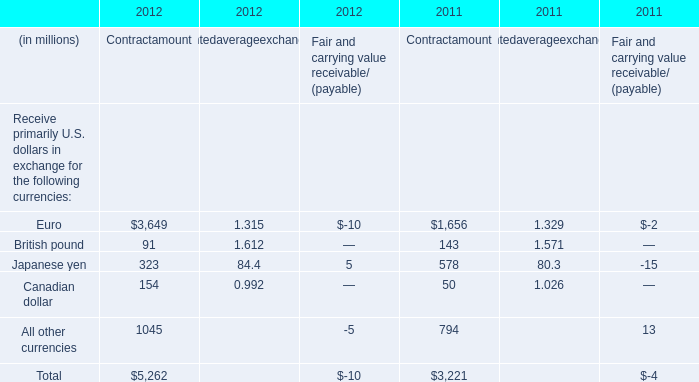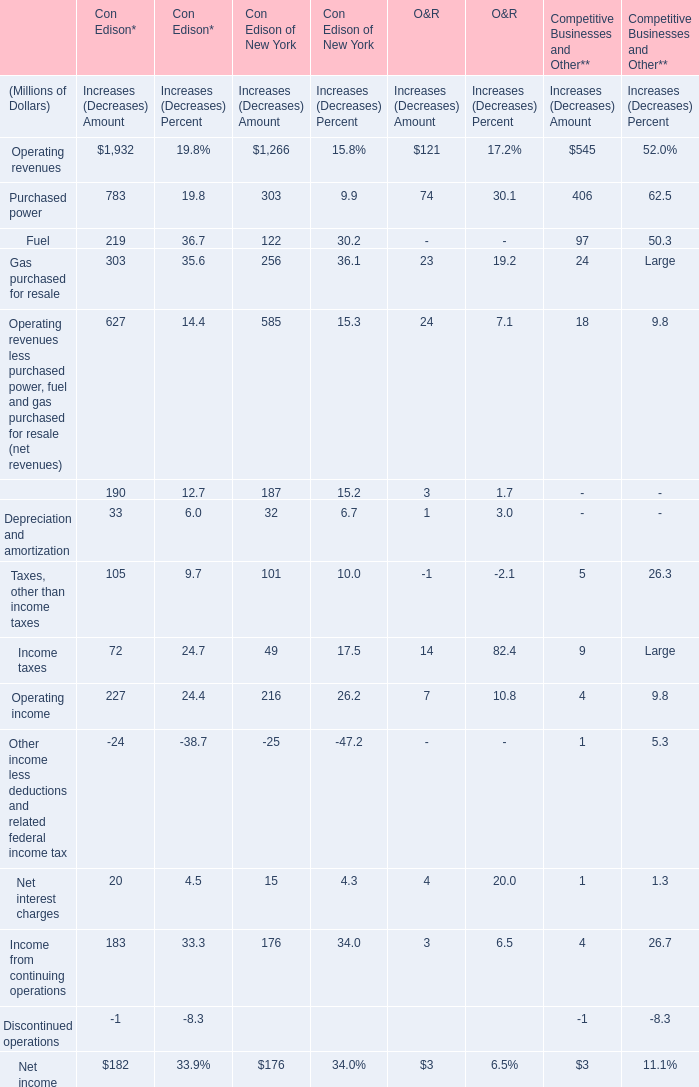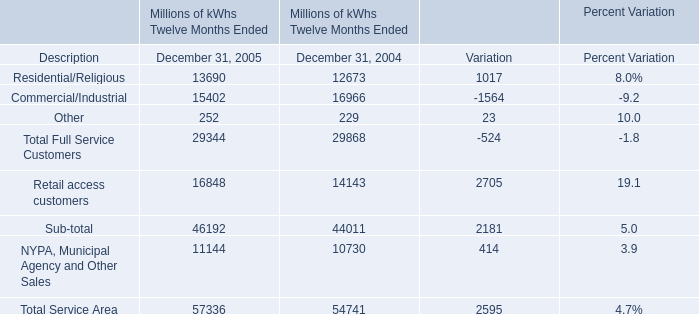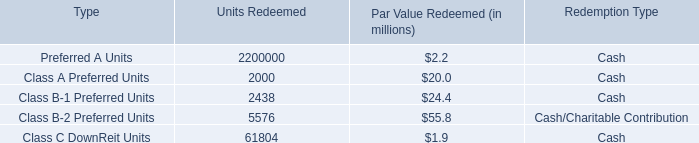What is the percentage of NYPA, Municipal Agency and Other Sales in relation to the total in 2005? 
Computations: (11144 / 57336)
Answer: 0.19436. 